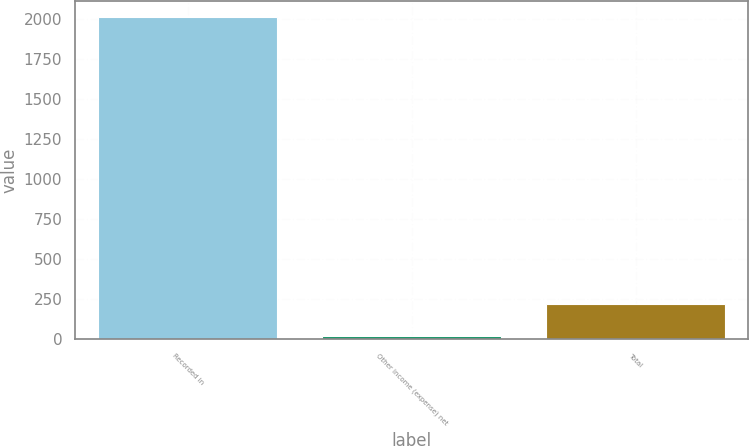<chart> <loc_0><loc_0><loc_500><loc_500><bar_chart><fcel>Recorded in<fcel>Other income (expense) net<fcel>Total<nl><fcel>2016<fcel>19<fcel>218.7<nl></chart> 